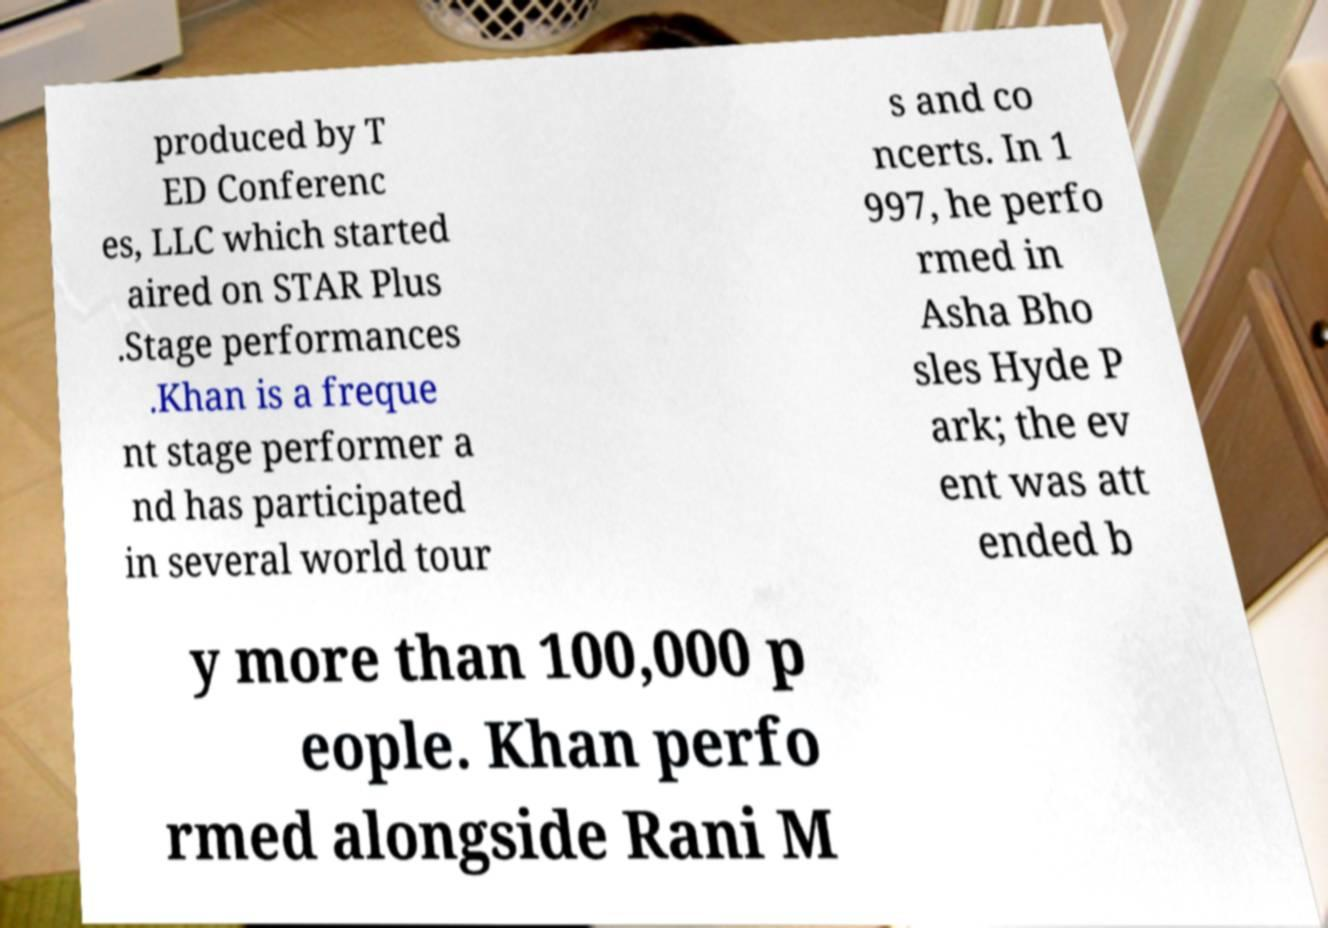Could you assist in decoding the text presented in this image and type it out clearly? produced by T ED Conferenc es, LLC which started aired on STAR Plus .Stage performances .Khan is a freque nt stage performer a nd has participated in several world tour s and co ncerts. In 1 997, he perfo rmed in Asha Bho sles Hyde P ark; the ev ent was att ended b y more than 100,000 p eople. Khan perfo rmed alongside Rani M 